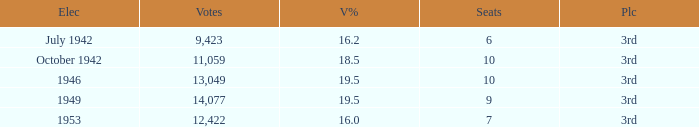Name the most vote % with election of 1946 19.5. 